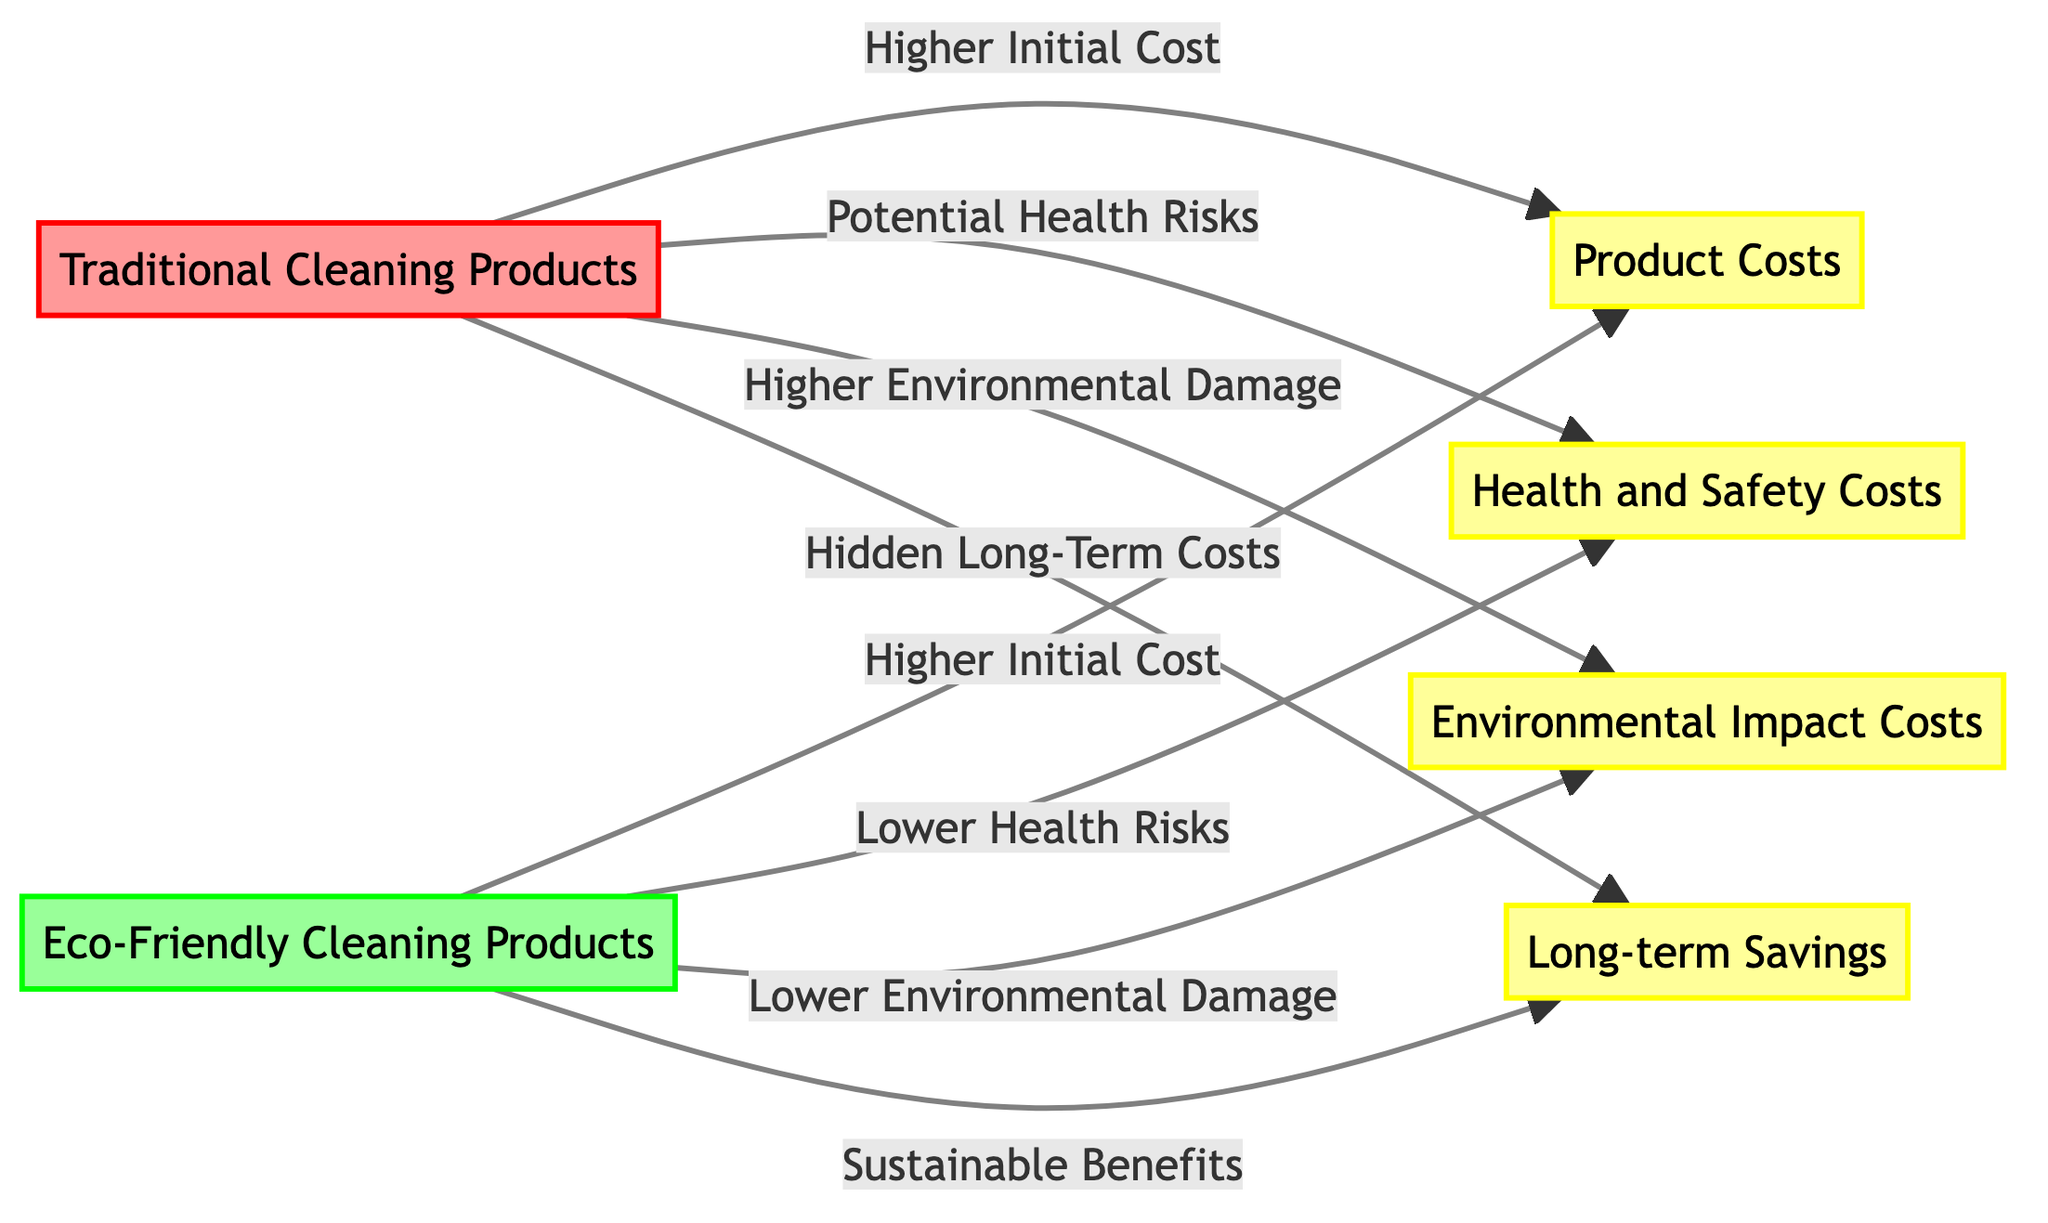What are the two types of cleaning products illustrated in the diagram? The diagram explicitly labels two types of cleaning products: Traditional Cleaning Products and Eco-Friendly Cleaning Products.
Answer: Traditional Cleaning Products, Eco-Friendly Cleaning Products What is the relationship between Traditional Cleaning Products and Environmental Damage? The diagram indicates that Traditional Cleaning Products are associated with Higher Environmental Damage, directly linking the two concepts through an edge.
Answer: Higher Environmental Damage How many cost factors are listed in the diagram? By reviewing the nodes, there are four cost factors identified: Product Costs, Health and Safety Costs, Environmental Impact Costs, and Long-term Savings. Thus, there are four cost factors.
Answer: Four Which type of cleaning product has Lower Health Risks? The diagram specifies that Eco-Friendly Cleaning Products have Lower Health Risks, distinguishing it from Traditional Cleaning Products that are linked with Potential Health Risks.
Answer: Eco-Friendly Cleaning Products What is the significance of Sustainable Benefits in the context of Eco-Friendly Cleaning Products? The diagram depicts Sustainable Benefits as directly linked to Eco-Friendly Cleaning Products, indicating that these products contribute positively over time, unlike Traditional Cleaning Products which have Hidden Long-Term Costs.
Answer: Sustainable Benefits Which cleaning product has Hidden Long-Term Costs? The diagram shows that Traditional Cleaning Products have Hidden Long-Term Costs, indicating potential expenses that may arise after the initial purchase.
Answer: Traditional Cleaning Products What do both types of cleaning products share in relation to initial costs? According to the diagram, both Traditional and Eco-Friendly Cleaning Products have Higher Initial Costs, indicating that both types require a considerable upfront investment.
Answer: Higher Initial Cost 